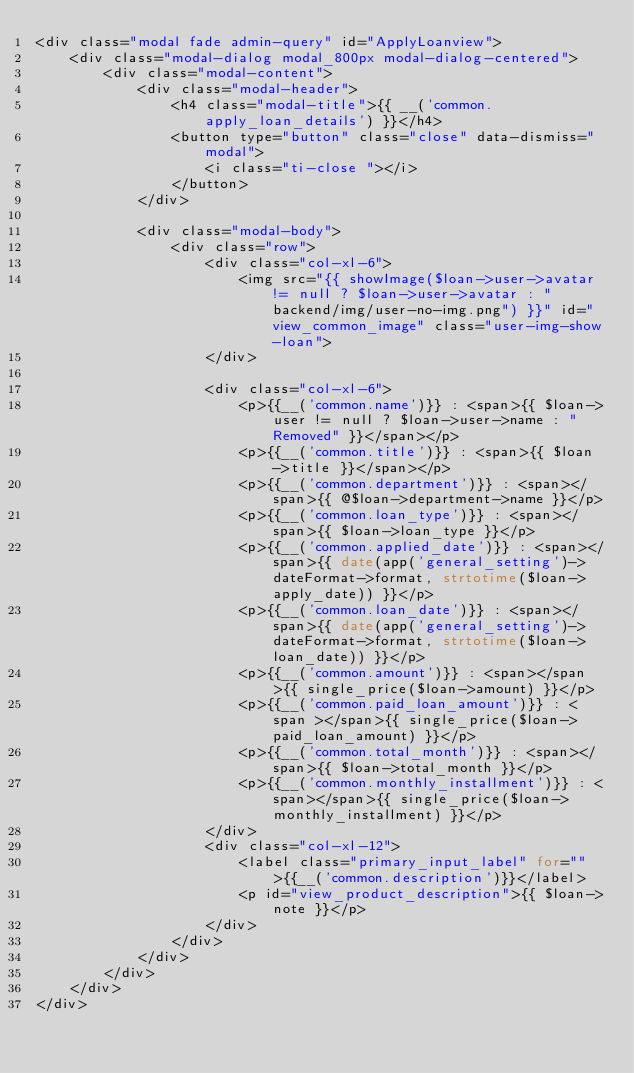Convert code to text. <code><loc_0><loc_0><loc_500><loc_500><_PHP_><div class="modal fade admin-query" id="ApplyLoanview">
    <div class="modal-dialog modal_800px modal-dialog-centered">
        <div class="modal-content">
            <div class="modal-header">
                <h4 class="modal-title">{{ __('common.apply_loan_details') }}</h4>
                <button type="button" class="close" data-dismiss="modal">
                    <i class="ti-close "></i>
                </button>
            </div>

            <div class="modal-body">
                <div class="row">
                    <div class="col-xl-6">
                        <img src="{{ showImage($loan->user->avatar!= null ? $loan->user->avatar : "backend/img/user-no-img.png") }}" id="view_common_image" class="user-img-show-loan">
                    </div>

                    <div class="col-xl-6">
                        <p>{{__('common.name')}} : <span>{{ $loan->user != null ? $loan->user->name : "Removed" }}</span></p>
                        <p>{{__('common.title')}} : <span>{{ $loan->title }}</span></p>
                        <p>{{__('common.department')}} : <span></span>{{ @$loan->department->name }}</p>
                        <p>{{__('common.loan_type')}} : <span></span>{{ $loan->loan_type }}</p>
                        <p>{{__('common.applied_date')}} : <span></span>{{ date(app('general_setting')->dateFormat->format, strtotime($loan->apply_date)) }}</p>
                        <p>{{__('common.loan_date')}} : <span></span>{{ date(app('general_setting')->dateFormat->format, strtotime($loan->loan_date)) }}</p>
                        <p>{{__('common.amount')}} : <span></span>{{ single_price($loan->amount) }}</p>
                        <p>{{__('common.paid_loan_amount')}} : <span ></span>{{ single_price($loan->paid_loan_amount) }}</p>
                        <p>{{__('common.total_month')}} : <span></span>{{ $loan->total_month }}</p>
                        <p>{{__('common.monthly_installment')}} : <span></span>{{ single_price($loan->monthly_installment) }}</p>
                    </div>
                    <div class="col-xl-12">
                        <label class="primary_input_label" for="">{{__('common.description')}}</label>
                        <p id="view_product_description">{{ $loan->note }}</p>
                    </div>
                </div>
            </div>
        </div>
    </div>
</div>
</code> 